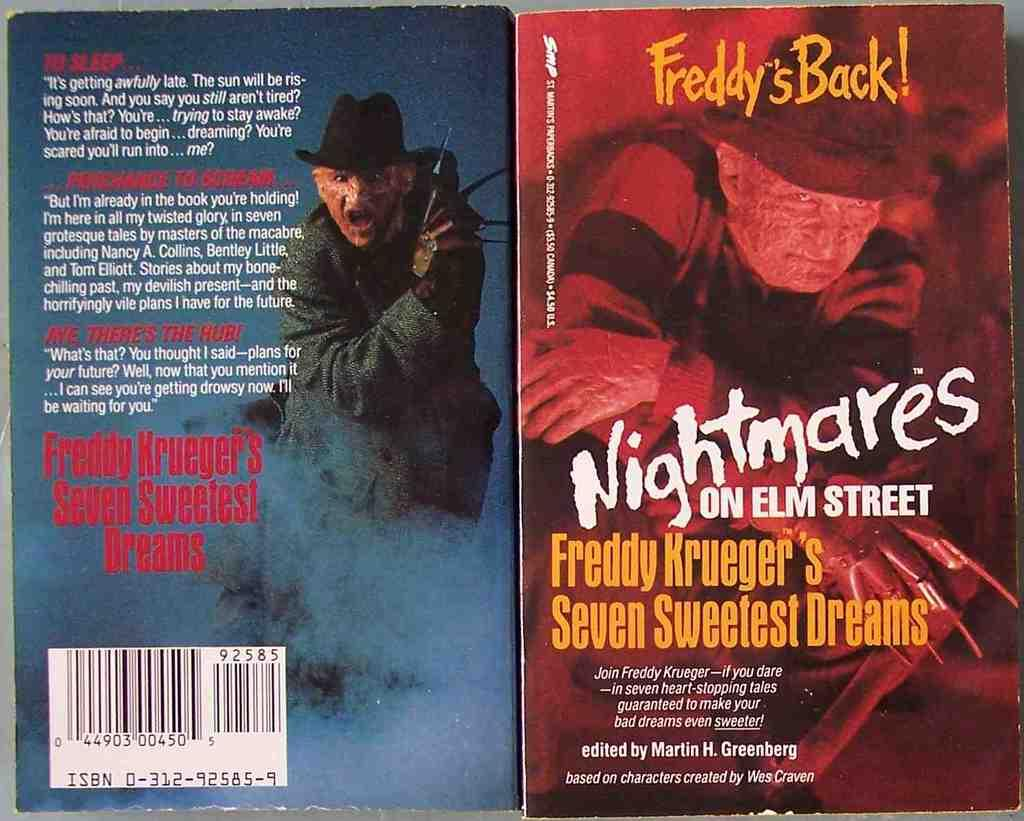<image>
Summarize the visual content of the image. The front and back cover of a Nightmares on Elm Street novel. 